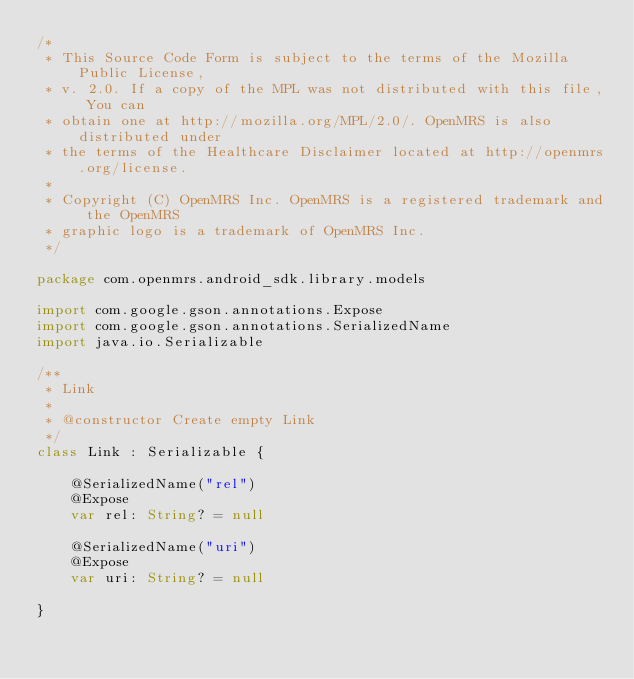Convert code to text. <code><loc_0><loc_0><loc_500><loc_500><_Kotlin_>/*
 * This Source Code Form is subject to the terms of the Mozilla Public License,
 * v. 2.0. If a copy of the MPL was not distributed with this file, You can
 * obtain one at http://mozilla.org/MPL/2.0/. OpenMRS is also distributed under
 * the terms of the Healthcare Disclaimer located at http://openmrs.org/license.
 *
 * Copyright (C) OpenMRS Inc. OpenMRS is a registered trademark and the OpenMRS
 * graphic logo is a trademark of OpenMRS Inc.
 */

package com.openmrs.android_sdk.library.models

import com.google.gson.annotations.Expose
import com.google.gson.annotations.SerializedName
import java.io.Serializable

/**
 * Link
 *
 * @constructor Create empty Link
 */
class Link : Serializable {

    @SerializedName("rel")
    @Expose
    var rel: String? = null

    @SerializedName("uri")
    @Expose
    var uri: String? = null

}
</code> 